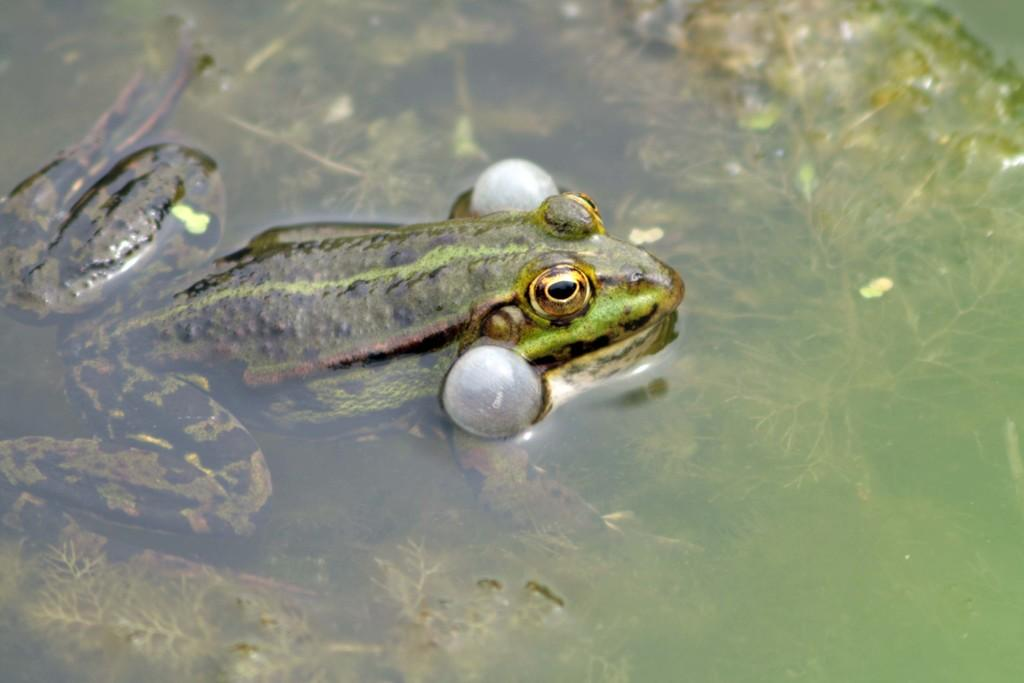What is the primary element in the image? There is water in the image. What can be found inside the water? There are plants and a frog inside the water. Can you describe the frog in the image? The frog has green, black, white, and brown colors. Can you tell me how many times the frog touched the lip in the image? There is no lip present in the image, so the frog cannot touch it. 